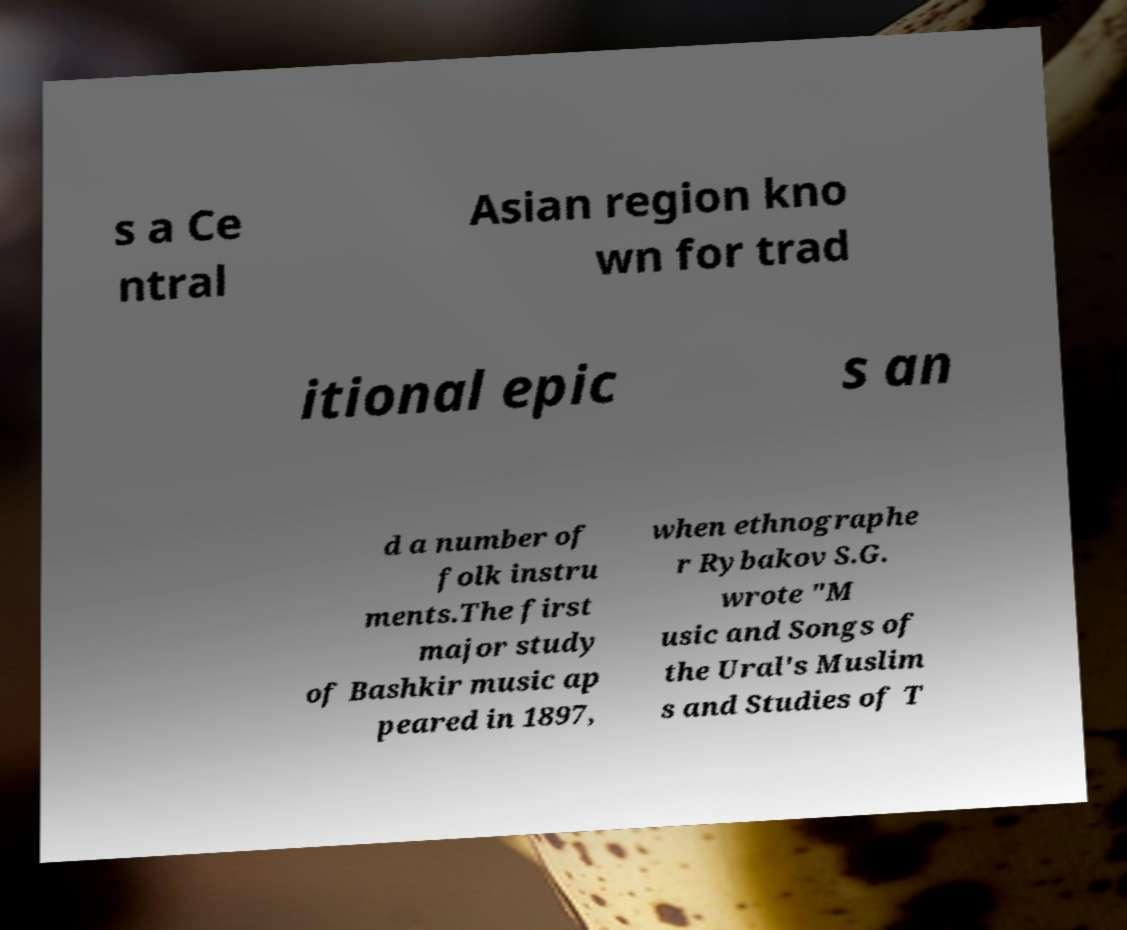Could you assist in decoding the text presented in this image and type it out clearly? s a Ce ntral Asian region kno wn for trad itional epic s an d a number of folk instru ments.The first major study of Bashkir music ap peared in 1897, when ethnographe r Rybakov S.G. wrote "M usic and Songs of the Ural's Muslim s and Studies of T 